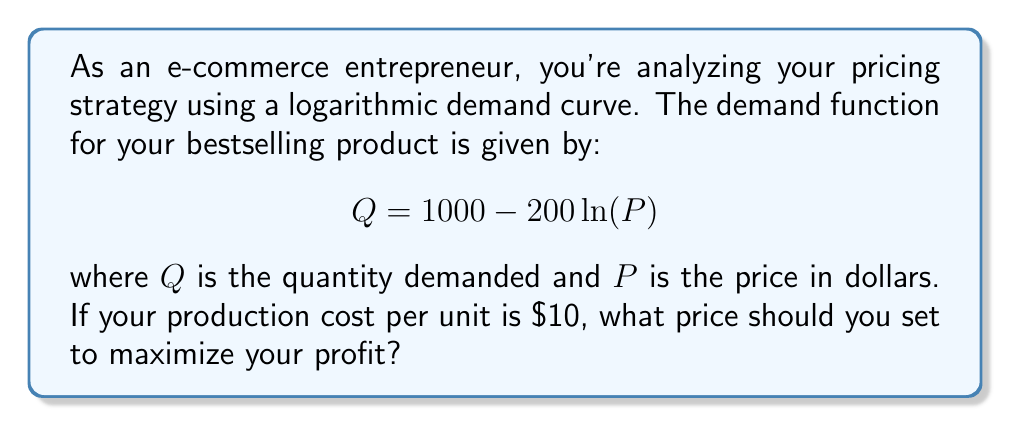Solve this math problem. To solve this problem, we'll follow these steps:

1) First, we need to formulate the profit function. Profit is revenue minus cost:
   $$ \text{Profit} = \text{Revenue} - \text{Cost} $$
   $$ \pi = PQ - 10Q $$

2) Substitute the demand function into the profit equation:
   $$ \pi = P(1000 - 200 \ln(P)) - 10(1000 - 200 \ln(P)) $$
   $$ \pi = 1000P - 200P\ln(P) - 10000 + 2000\ln(P) $$

3) To maximize profit, we need to find where the derivative of the profit function equals zero:
   $$ \frac{d\pi}{dP} = 1000 - 200\ln(P) - 200 + \frac{2000}{P} = 0 $$

4) Simplify the equation:
   $$ 800 - 200\ln(P) + \frac{2000}{P} = 0 $$

5) Multiply both sides by $P$:
   $$ 800P - 200P\ln(P) + 2000 = 0 $$

6) This equation can't be solved algebraically. We need to use numerical methods or a graphing calculator to find that the solution is approximately:
   $$ P \approx 36.79 $$

7) To confirm this is a maximum (not a minimum), we can check the second derivative is negative at this point (omitted for brevity).
Answer: The optimal price to maximize profit is approximately $36.79. 